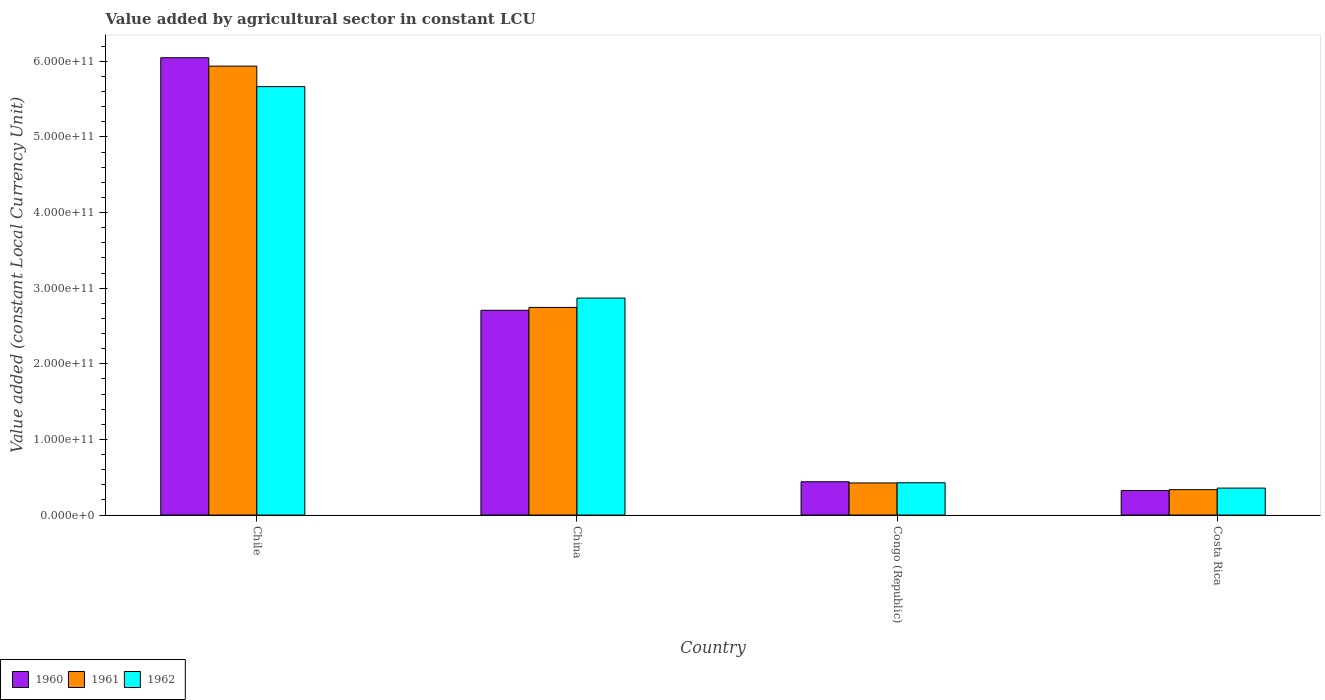How many different coloured bars are there?
Your answer should be very brief. 3. How many groups of bars are there?
Keep it short and to the point. 4. Are the number of bars per tick equal to the number of legend labels?
Provide a succinct answer. Yes. Are the number of bars on each tick of the X-axis equal?
Ensure brevity in your answer.  Yes. How many bars are there on the 4th tick from the left?
Offer a terse response. 3. How many bars are there on the 2nd tick from the right?
Your answer should be very brief. 3. What is the label of the 2nd group of bars from the left?
Your response must be concise. China. In how many cases, is the number of bars for a given country not equal to the number of legend labels?
Make the answer very short. 0. What is the value added by agricultural sector in 1961 in Costa Rica?
Make the answer very short. 3.36e+1. Across all countries, what is the maximum value added by agricultural sector in 1960?
Offer a terse response. 6.05e+11. Across all countries, what is the minimum value added by agricultural sector in 1962?
Ensure brevity in your answer.  3.57e+1. What is the total value added by agricultural sector in 1960 in the graph?
Keep it short and to the point. 9.52e+11. What is the difference between the value added by agricultural sector in 1961 in Chile and that in Congo (Republic)?
Make the answer very short. 5.51e+11. What is the difference between the value added by agricultural sector in 1962 in China and the value added by agricultural sector in 1961 in Costa Rica?
Ensure brevity in your answer.  2.53e+11. What is the average value added by agricultural sector in 1961 per country?
Offer a terse response. 2.36e+11. What is the difference between the value added by agricultural sector of/in 1961 and value added by agricultural sector of/in 1962 in Congo (Republic)?
Your answer should be very brief. -2.56e+08. What is the ratio of the value added by agricultural sector in 1960 in China to that in Congo (Republic)?
Your answer should be very brief. 6.15. Is the value added by agricultural sector in 1960 in China less than that in Congo (Republic)?
Your answer should be compact. No. What is the difference between the highest and the second highest value added by agricultural sector in 1960?
Give a very brief answer. -3.34e+11. What is the difference between the highest and the lowest value added by agricultural sector in 1962?
Provide a short and direct response. 5.31e+11. In how many countries, is the value added by agricultural sector in 1961 greater than the average value added by agricultural sector in 1961 taken over all countries?
Keep it short and to the point. 2. Is it the case that in every country, the sum of the value added by agricultural sector in 1961 and value added by agricultural sector in 1962 is greater than the value added by agricultural sector in 1960?
Your response must be concise. Yes. How many bars are there?
Offer a terse response. 12. What is the difference between two consecutive major ticks on the Y-axis?
Offer a terse response. 1.00e+11. Are the values on the major ticks of Y-axis written in scientific E-notation?
Offer a terse response. Yes. How many legend labels are there?
Make the answer very short. 3. What is the title of the graph?
Provide a short and direct response. Value added by agricultural sector in constant LCU. What is the label or title of the Y-axis?
Your answer should be compact. Value added (constant Local Currency Unit). What is the Value added (constant Local Currency Unit) in 1960 in Chile?
Offer a terse response. 6.05e+11. What is the Value added (constant Local Currency Unit) of 1961 in Chile?
Your answer should be very brief. 5.94e+11. What is the Value added (constant Local Currency Unit) of 1962 in Chile?
Ensure brevity in your answer.  5.67e+11. What is the Value added (constant Local Currency Unit) of 1960 in China?
Your answer should be compact. 2.71e+11. What is the Value added (constant Local Currency Unit) of 1961 in China?
Give a very brief answer. 2.75e+11. What is the Value added (constant Local Currency Unit) of 1962 in China?
Offer a very short reply. 2.87e+11. What is the Value added (constant Local Currency Unit) in 1960 in Congo (Republic)?
Your response must be concise. 4.41e+1. What is the Value added (constant Local Currency Unit) of 1961 in Congo (Republic)?
Offer a very short reply. 4.25e+1. What is the Value added (constant Local Currency Unit) of 1962 in Congo (Republic)?
Offer a terse response. 4.27e+1. What is the Value added (constant Local Currency Unit) of 1960 in Costa Rica?
Ensure brevity in your answer.  3.24e+1. What is the Value added (constant Local Currency Unit) in 1961 in Costa Rica?
Provide a succinct answer. 3.36e+1. What is the Value added (constant Local Currency Unit) in 1962 in Costa Rica?
Your response must be concise. 3.57e+1. Across all countries, what is the maximum Value added (constant Local Currency Unit) of 1960?
Offer a terse response. 6.05e+11. Across all countries, what is the maximum Value added (constant Local Currency Unit) of 1961?
Keep it short and to the point. 5.94e+11. Across all countries, what is the maximum Value added (constant Local Currency Unit) in 1962?
Ensure brevity in your answer.  5.67e+11. Across all countries, what is the minimum Value added (constant Local Currency Unit) of 1960?
Give a very brief answer. 3.24e+1. Across all countries, what is the minimum Value added (constant Local Currency Unit) in 1961?
Your answer should be very brief. 3.36e+1. Across all countries, what is the minimum Value added (constant Local Currency Unit) in 1962?
Provide a succinct answer. 3.57e+1. What is the total Value added (constant Local Currency Unit) of 1960 in the graph?
Provide a short and direct response. 9.52e+11. What is the total Value added (constant Local Currency Unit) of 1961 in the graph?
Offer a terse response. 9.44e+11. What is the total Value added (constant Local Currency Unit) in 1962 in the graph?
Your response must be concise. 9.32e+11. What is the difference between the Value added (constant Local Currency Unit) of 1960 in Chile and that in China?
Your answer should be very brief. 3.34e+11. What is the difference between the Value added (constant Local Currency Unit) in 1961 in Chile and that in China?
Offer a very short reply. 3.19e+11. What is the difference between the Value added (constant Local Currency Unit) in 1962 in Chile and that in China?
Your answer should be very brief. 2.80e+11. What is the difference between the Value added (constant Local Currency Unit) in 1960 in Chile and that in Congo (Republic)?
Give a very brief answer. 5.61e+11. What is the difference between the Value added (constant Local Currency Unit) in 1961 in Chile and that in Congo (Republic)?
Your response must be concise. 5.51e+11. What is the difference between the Value added (constant Local Currency Unit) in 1962 in Chile and that in Congo (Republic)?
Provide a succinct answer. 5.24e+11. What is the difference between the Value added (constant Local Currency Unit) in 1960 in Chile and that in Costa Rica?
Make the answer very short. 5.72e+11. What is the difference between the Value added (constant Local Currency Unit) in 1961 in Chile and that in Costa Rica?
Provide a succinct answer. 5.60e+11. What is the difference between the Value added (constant Local Currency Unit) of 1962 in Chile and that in Costa Rica?
Keep it short and to the point. 5.31e+11. What is the difference between the Value added (constant Local Currency Unit) in 1960 in China and that in Congo (Republic)?
Offer a very short reply. 2.27e+11. What is the difference between the Value added (constant Local Currency Unit) of 1961 in China and that in Congo (Republic)?
Give a very brief answer. 2.32e+11. What is the difference between the Value added (constant Local Currency Unit) in 1962 in China and that in Congo (Republic)?
Offer a terse response. 2.44e+11. What is the difference between the Value added (constant Local Currency Unit) in 1960 in China and that in Costa Rica?
Your answer should be very brief. 2.38e+11. What is the difference between the Value added (constant Local Currency Unit) in 1961 in China and that in Costa Rica?
Your response must be concise. 2.41e+11. What is the difference between the Value added (constant Local Currency Unit) of 1962 in China and that in Costa Rica?
Provide a short and direct response. 2.51e+11. What is the difference between the Value added (constant Local Currency Unit) of 1960 in Congo (Republic) and that in Costa Rica?
Your answer should be compact. 1.17e+1. What is the difference between the Value added (constant Local Currency Unit) of 1961 in Congo (Republic) and that in Costa Rica?
Offer a terse response. 8.89e+09. What is the difference between the Value added (constant Local Currency Unit) of 1962 in Congo (Republic) and that in Costa Rica?
Offer a very short reply. 7.08e+09. What is the difference between the Value added (constant Local Currency Unit) of 1960 in Chile and the Value added (constant Local Currency Unit) of 1961 in China?
Provide a succinct answer. 3.30e+11. What is the difference between the Value added (constant Local Currency Unit) in 1960 in Chile and the Value added (constant Local Currency Unit) in 1962 in China?
Offer a terse response. 3.18e+11. What is the difference between the Value added (constant Local Currency Unit) in 1961 in Chile and the Value added (constant Local Currency Unit) in 1962 in China?
Your response must be concise. 3.07e+11. What is the difference between the Value added (constant Local Currency Unit) of 1960 in Chile and the Value added (constant Local Currency Unit) of 1961 in Congo (Republic)?
Your response must be concise. 5.62e+11. What is the difference between the Value added (constant Local Currency Unit) of 1960 in Chile and the Value added (constant Local Currency Unit) of 1962 in Congo (Republic)?
Your answer should be very brief. 5.62e+11. What is the difference between the Value added (constant Local Currency Unit) of 1961 in Chile and the Value added (constant Local Currency Unit) of 1962 in Congo (Republic)?
Provide a short and direct response. 5.51e+11. What is the difference between the Value added (constant Local Currency Unit) of 1960 in Chile and the Value added (constant Local Currency Unit) of 1961 in Costa Rica?
Keep it short and to the point. 5.71e+11. What is the difference between the Value added (constant Local Currency Unit) of 1960 in Chile and the Value added (constant Local Currency Unit) of 1962 in Costa Rica?
Make the answer very short. 5.69e+11. What is the difference between the Value added (constant Local Currency Unit) in 1961 in Chile and the Value added (constant Local Currency Unit) in 1962 in Costa Rica?
Ensure brevity in your answer.  5.58e+11. What is the difference between the Value added (constant Local Currency Unit) in 1960 in China and the Value added (constant Local Currency Unit) in 1961 in Congo (Republic)?
Your answer should be compact. 2.28e+11. What is the difference between the Value added (constant Local Currency Unit) in 1960 in China and the Value added (constant Local Currency Unit) in 1962 in Congo (Republic)?
Provide a succinct answer. 2.28e+11. What is the difference between the Value added (constant Local Currency Unit) in 1961 in China and the Value added (constant Local Currency Unit) in 1962 in Congo (Republic)?
Offer a very short reply. 2.32e+11. What is the difference between the Value added (constant Local Currency Unit) in 1960 in China and the Value added (constant Local Currency Unit) in 1961 in Costa Rica?
Offer a terse response. 2.37e+11. What is the difference between the Value added (constant Local Currency Unit) in 1960 in China and the Value added (constant Local Currency Unit) in 1962 in Costa Rica?
Make the answer very short. 2.35e+11. What is the difference between the Value added (constant Local Currency Unit) in 1961 in China and the Value added (constant Local Currency Unit) in 1962 in Costa Rica?
Give a very brief answer. 2.39e+11. What is the difference between the Value added (constant Local Currency Unit) in 1960 in Congo (Republic) and the Value added (constant Local Currency Unit) in 1961 in Costa Rica?
Make the answer very short. 1.05e+1. What is the difference between the Value added (constant Local Currency Unit) in 1960 in Congo (Republic) and the Value added (constant Local Currency Unit) in 1962 in Costa Rica?
Provide a succinct answer. 8.40e+09. What is the difference between the Value added (constant Local Currency Unit) in 1961 in Congo (Republic) and the Value added (constant Local Currency Unit) in 1962 in Costa Rica?
Make the answer very short. 6.83e+09. What is the average Value added (constant Local Currency Unit) in 1960 per country?
Your answer should be very brief. 2.38e+11. What is the average Value added (constant Local Currency Unit) in 1961 per country?
Keep it short and to the point. 2.36e+11. What is the average Value added (constant Local Currency Unit) in 1962 per country?
Offer a terse response. 2.33e+11. What is the difference between the Value added (constant Local Currency Unit) of 1960 and Value added (constant Local Currency Unit) of 1961 in Chile?
Your answer should be compact. 1.11e+1. What is the difference between the Value added (constant Local Currency Unit) in 1960 and Value added (constant Local Currency Unit) in 1962 in Chile?
Provide a succinct answer. 3.82e+1. What is the difference between the Value added (constant Local Currency Unit) in 1961 and Value added (constant Local Currency Unit) in 1962 in Chile?
Your answer should be very brief. 2.70e+1. What is the difference between the Value added (constant Local Currency Unit) of 1960 and Value added (constant Local Currency Unit) of 1961 in China?
Provide a succinct answer. -3.79e+09. What is the difference between the Value added (constant Local Currency Unit) in 1960 and Value added (constant Local Currency Unit) in 1962 in China?
Offer a terse response. -1.61e+1. What is the difference between the Value added (constant Local Currency Unit) of 1961 and Value added (constant Local Currency Unit) of 1962 in China?
Your answer should be compact. -1.24e+1. What is the difference between the Value added (constant Local Currency Unit) in 1960 and Value added (constant Local Currency Unit) in 1961 in Congo (Republic)?
Your answer should be compact. 1.57e+09. What is the difference between the Value added (constant Local Currency Unit) in 1960 and Value added (constant Local Currency Unit) in 1962 in Congo (Republic)?
Your response must be concise. 1.32e+09. What is the difference between the Value added (constant Local Currency Unit) of 1961 and Value added (constant Local Currency Unit) of 1962 in Congo (Republic)?
Your response must be concise. -2.56e+08. What is the difference between the Value added (constant Local Currency Unit) of 1960 and Value added (constant Local Currency Unit) of 1961 in Costa Rica?
Provide a succinct answer. -1.19e+09. What is the difference between the Value added (constant Local Currency Unit) of 1960 and Value added (constant Local Currency Unit) of 1962 in Costa Rica?
Provide a short and direct response. -3.25e+09. What is the difference between the Value added (constant Local Currency Unit) of 1961 and Value added (constant Local Currency Unit) of 1962 in Costa Rica?
Keep it short and to the point. -2.06e+09. What is the ratio of the Value added (constant Local Currency Unit) in 1960 in Chile to that in China?
Your answer should be compact. 2.23. What is the ratio of the Value added (constant Local Currency Unit) in 1961 in Chile to that in China?
Make the answer very short. 2.16. What is the ratio of the Value added (constant Local Currency Unit) in 1962 in Chile to that in China?
Keep it short and to the point. 1.97. What is the ratio of the Value added (constant Local Currency Unit) in 1960 in Chile to that in Congo (Republic)?
Offer a very short reply. 13.73. What is the ratio of the Value added (constant Local Currency Unit) in 1961 in Chile to that in Congo (Republic)?
Ensure brevity in your answer.  13.97. What is the ratio of the Value added (constant Local Currency Unit) in 1962 in Chile to that in Congo (Republic)?
Your answer should be very brief. 13.26. What is the ratio of the Value added (constant Local Currency Unit) in 1960 in Chile to that in Costa Rica?
Give a very brief answer. 18.66. What is the ratio of the Value added (constant Local Currency Unit) in 1961 in Chile to that in Costa Rica?
Offer a terse response. 17.67. What is the ratio of the Value added (constant Local Currency Unit) in 1962 in Chile to that in Costa Rica?
Your answer should be compact. 15.89. What is the ratio of the Value added (constant Local Currency Unit) in 1960 in China to that in Congo (Republic)?
Provide a succinct answer. 6.15. What is the ratio of the Value added (constant Local Currency Unit) in 1961 in China to that in Congo (Republic)?
Your answer should be very brief. 6.46. What is the ratio of the Value added (constant Local Currency Unit) in 1962 in China to that in Congo (Republic)?
Offer a very short reply. 6.71. What is the ratio of the Value added (constant Local Currency Unit) of 1960 in China to that in Costa Rica?
Offer a very short reply. 8.36. What is the ratio of the Value added (constant Local Currency Unit) in 1961 in China to that in Costa Rica?
Make the answer very short. 8.17. What is the ratio of the Value added (constant Local Currency Unit) in 1962 in China to that in Costa Rica?
Give a very brief answer. 8.05. What is the ratio of the Value added (constant Local Currency Unit) of 1960 in Congo (Republic) to that in Costa Rica?
Offer a terse response. 1.36. What is the ratio of the Value added (constant Local Currency Unit) of 1961 in Congo (Republic) to that in Costa Rica?
Your answer should be very brief. 1.26. What is the ratio of the Value added (constant Local Currency Unit) of 1962 in Congo (Republic) to that in Costa Rica?
Make the answer very short. 1.2. What is the difference between the highest and the second highest Value added (constant Local Currency Unit) in 1960?
Your answer should be compact. 3.34e+11. What is the difference between the highest and the second highest Value added (constant Local Currency Unit) of 1961?
Your response must be concise. 3.19e+11. What is the difference between the highest and the second highest Value added (constant Local Currency Unit) in 1962?
Provide a succinct answer. 2.80e+11. What is the difference between the highest and the lowest Value added (constant Local Currency Unit) of 1960?
Offer a very short reply. 5.72e+11. What is the difference between the highest and the lowest Value added (constant Local Currency Unit) in 1961?
Your answer should be very brief. 5.60e+11. What is the difference between the highest and the lowest Value added (constant Local Currency Unit) in 1962?
Make the answer very short. 5.31e+11. 